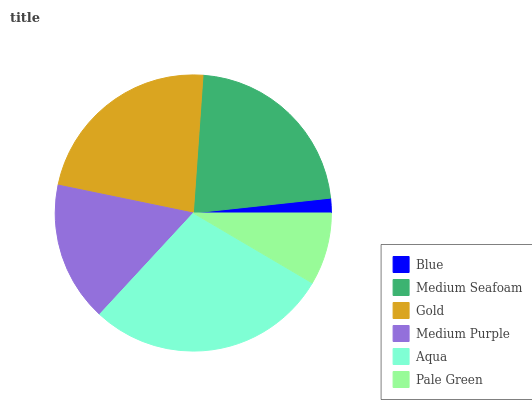Is Blue the minimum?
Answer yes or no. Yes. Is Aqua the maximum?
Answer yes or no. Yes. Is Medium Seafoam the minimum?
Answer yes or no. No. Is Medium Seafoam the maximum?
Answer yes or no. No. Is Medium Seafoam greater than Blue?
Answer yes or no. Yes. Is Blue less than Medium Seafoam?
Answer yes or no. Yes. Is Blue greater than Medium Seafoam?
Answer yes or no. No. Is Medium Seafoam less than Blue?
Answer yes or no. No. Is Medium Seafoam the high median?
Answer yes or no. Yes. Is Medium Purple the low median?
Answer yes or no. Yes. Is Gold the high median?
Answer yes or no. No. Is Blue the low median?
Answer yes or no. No. 